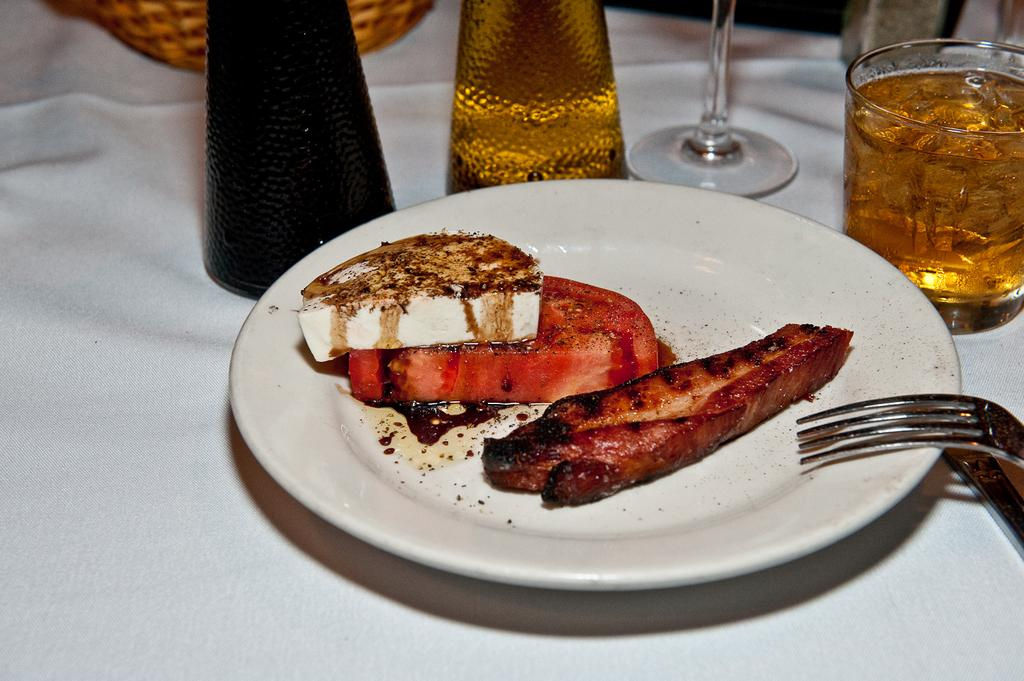What is the color of the surface where the food items are placed? The surface is white. What is placed on the white surface? There is a plate with food items on the white surface. What utensil can be seen in the image? There is a fork visible in the image. What else is present on the white surface besides the plate with food items? There are glasses with drinks in the image. What type of rhythm can be heard coming from the store in the image? There is no store or rhythm present in the image; it features a white surface with a plate of food items, a fork, and glasses with drinks. 